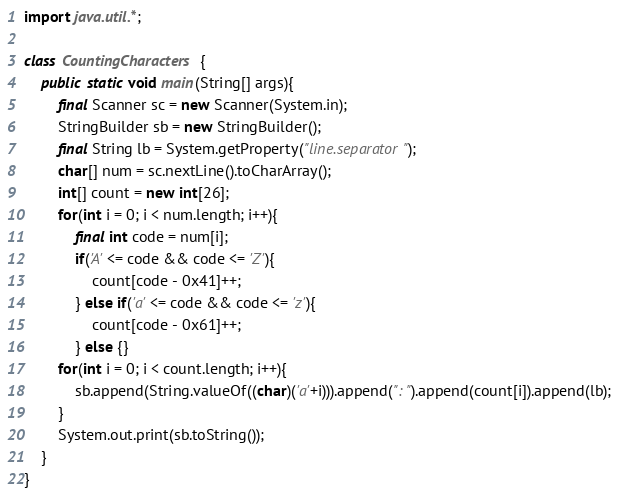Convert code to text. <code><loc_0><loc_0><loc_500><loc_500><_Java_>import java.util.*;

class CountingCharacters {
	public static void main(String[] args){
		final Scanner sc = new Scanner(System.in);
		StringBuilder sb = new StringBuilder();
		final String lb = System.getProperty("line.separator");
		char[] num = sc.nextLine().toCharArray();
		int[] count = new int[26];
		for(int i = 0; i < num.length; i++){
			final int code = num[i];
			if('A' <= code && code <= 'Z'){
				count[code - 0x41]++;
			} else if('a' <= code && code <= 'z'){
				count[code - 0x61]++;
			} else {}
		for(int i = 0; i < count.length; i++){
			sb.append(String.valueOf((char)('a'+i))).append(": ").append(count[i]).append(lb);
		}
		System.out.print(sb.toString());
	}
}</code> 